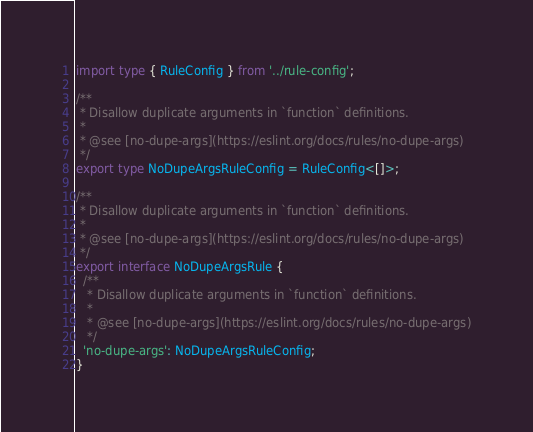Convert code to text. <code><loc_0><loc_0><loc_500><loc_500><_TypeScript_>import type { RuleConfig } from '../rule-config';

/**
 * Disallow duplicate arguments in `function` definitions.
 *
 * @see [no-dupe-args](https://eslint.org/docs/rules/no-dupe-args)
 */
export type NoDupeArgsRuleConfig = RuleConfig<[]>;

/**
 * Disallow duplicate arguments in `function` definitions.
 *
 * @see [no-dupe-args](https://eslint.org/docs/rules/no-dupe-args)
 */
export interface NoDupeArgsRule {
  /**
   * Disallow duplicate arguments in `function` definitions.
   *
   * @see [no-dupe-args](https://eslint.org/docs/rules/no-dupe-args)
   */
  'no-dupe-args': NoDupeArgsRuleConfig;
}
</code> 